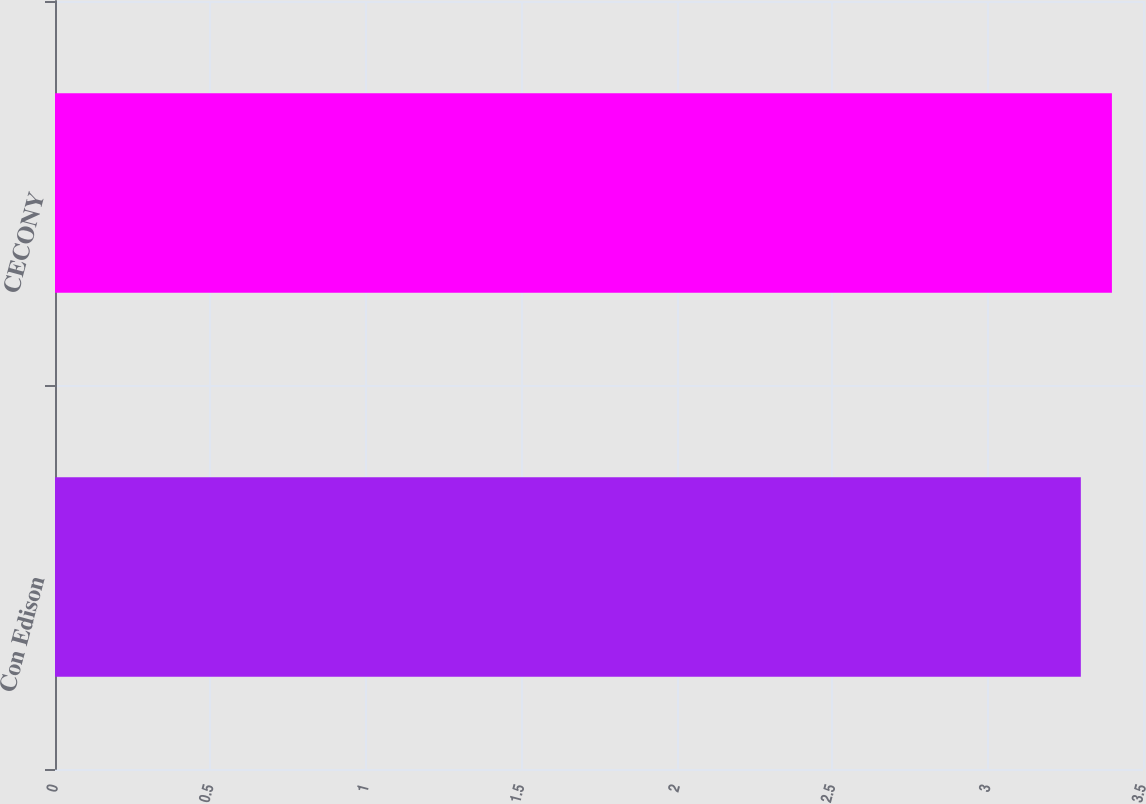<chart> <loc_0><loc_0><loc_500><loc_500><bar_chart><fcel>Con Edison<fcel>CECONY<nl><fcel>3.3<fcel>3.4<nl></chart> 